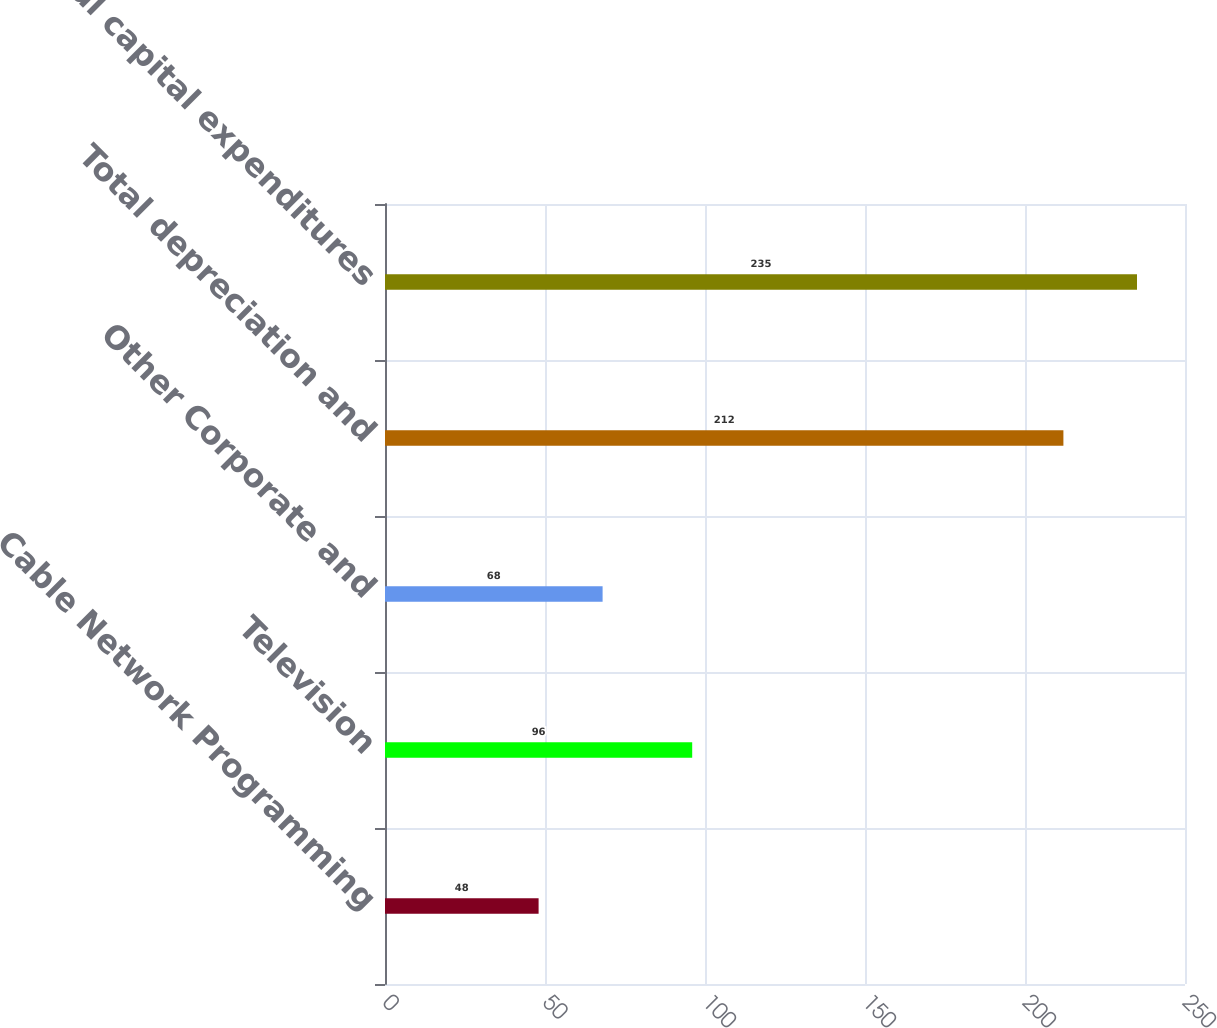<chart> <loc_0><loc_0><loc_500><loc_500><bar_chart><fcel>Cable Network Programming<fcel>Television<fcel>Other Corporate and<fcel>Total depreciation and<fcel>Total capital expenditures<nl><fcel>48<fcel>96<fcel>68<fcel>212<fcel>235<nl></chart> 